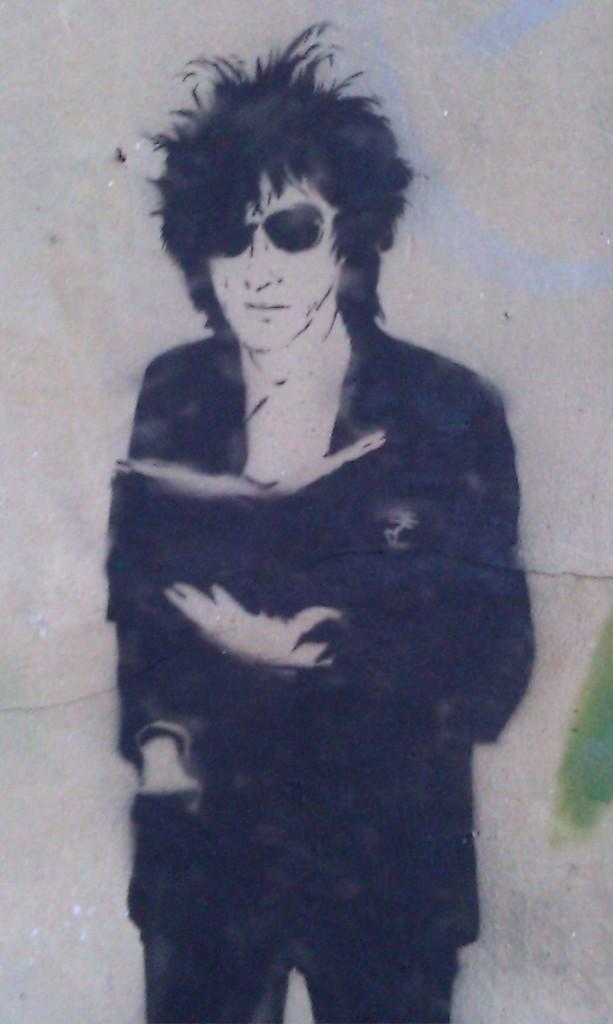What is the main subject of the painting? The painting depicts a person. What is the person wearing in the painting? The person is wearing a black dress. What is the person holding in the painting? The person is holding a book. What is the color of the background in the painting? The background of the painting is gray in color. Can you see any wounds on the person in the painting? There is no mention of any wounds on the person in the painting, so we cannot determine if any are present. 